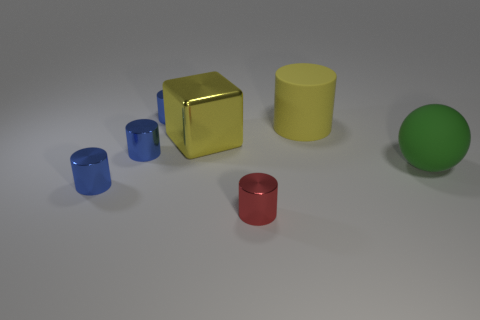Is the number of small blue cylinders that are in front of the green rubber thing greater than the number of gray metal spheres?
Give a very brief answer. Yes. What is the material of the green sphere to the right of the big thing behind the large block that is to the left of the yellow matte thing?
Offer a terse response. Rubber. How many objects are either yellow cylinders or tiny metallic things that are in front of the large cylinder?
Provide a succinct answer. 4. There is a large matte object left of the large green thing; is it the same color as the block?
Give a very brief answer. Yes. Is the number of tiny blue objects behind the large green rubber sphere greater than the number of large rubber things that are to the left of the yellow metallic object?
Provide a succinct answer. Yes. Is there any other thing that has the same color as the large cylinder?
Provide a succinct answer. Yes. How many objects are brown matte cubes or metallic objects?
Provide a succinct answer. 5. Do the blue metal cylinder behind the yellow rubber cylinder and the red metal thing have the same size?
Provide a short and direct response. Yes. How many other things are there of the same size as the green matte ball?
Provide a short and direct response. 2. Are there any purple rubber objects?
Ensure brevity in your answer.  No. 